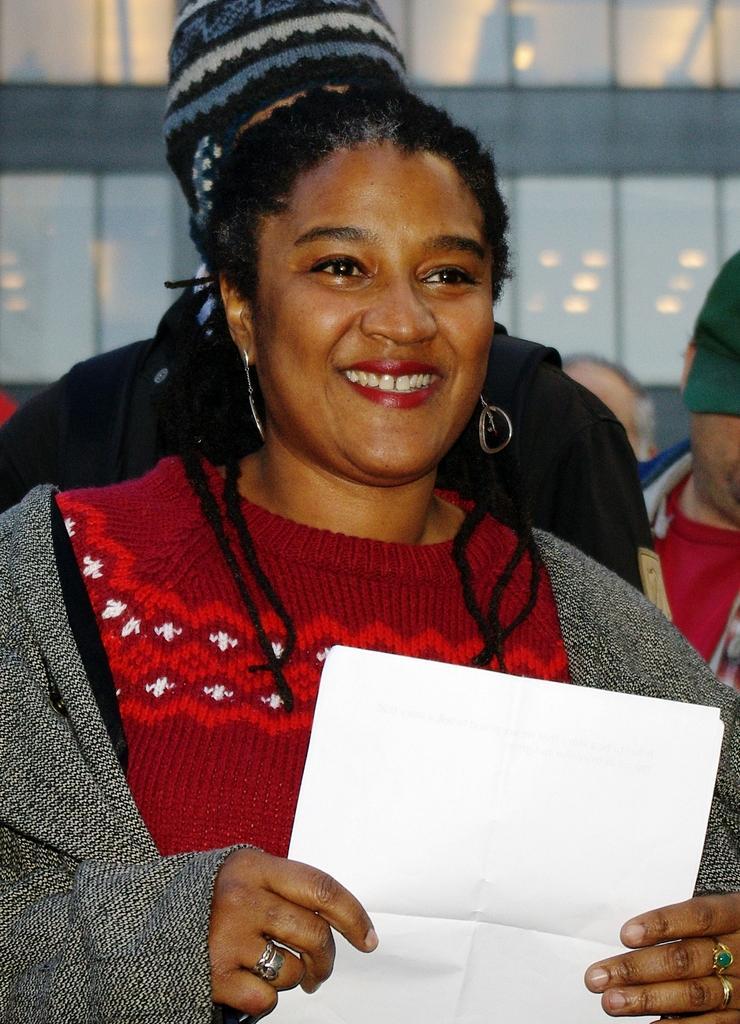In one or two sentences, can you explain what this image depicts? This image consists of a woman wearing a gray jacket and holding papers. In the background, there are many people. And we can see a building. 